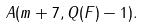<formula> <loc_0><loc_0><loc_500><loc_500>A ( m + 7 , Q ( F ) - 1 ) .</formula> 